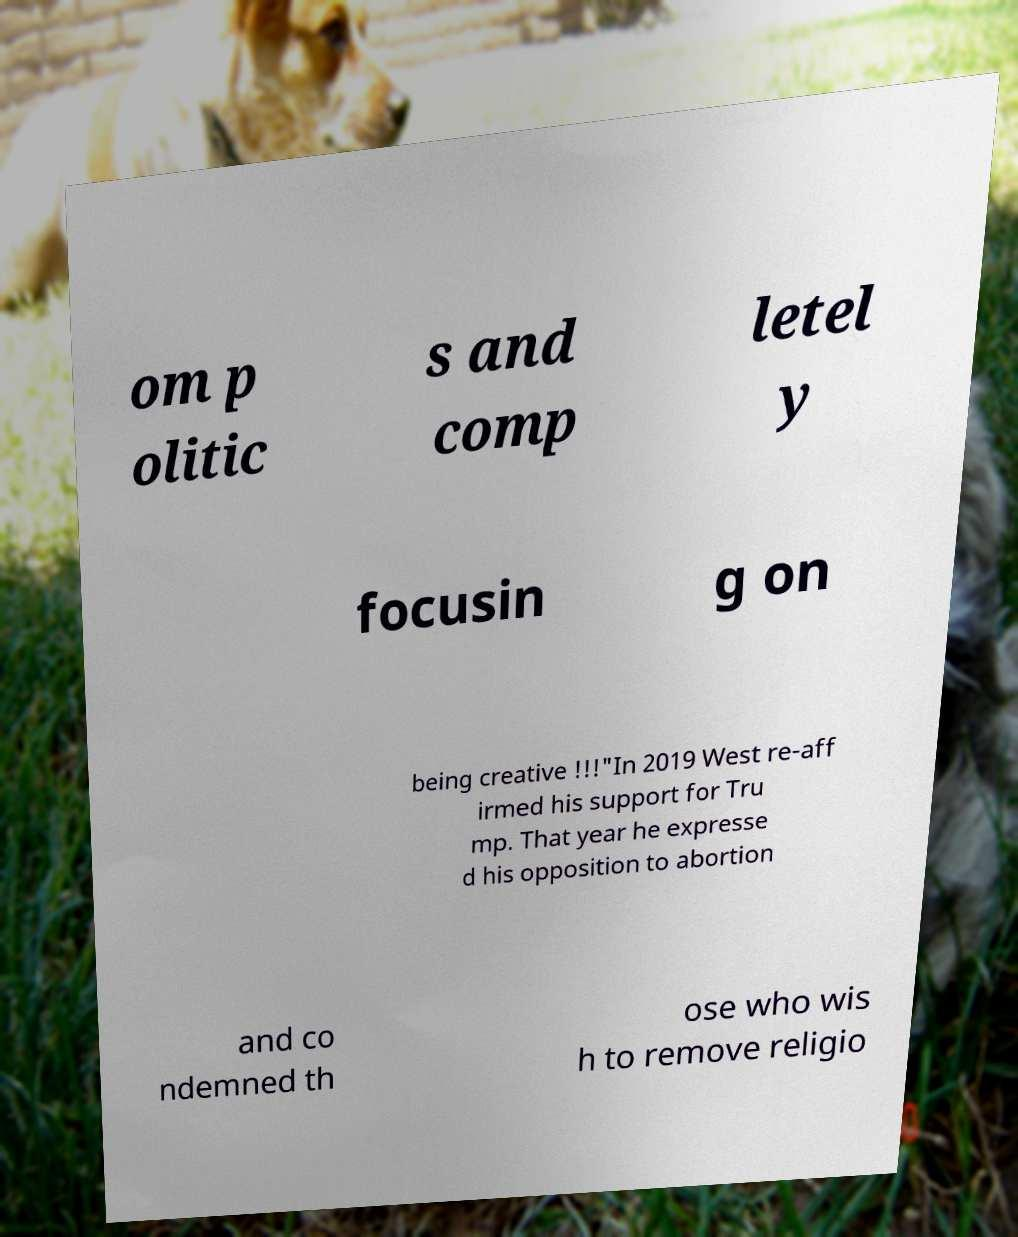There's text embedded in this image that I need extracted. Can you transcribe it verbatim? om p olitic s and comp letel y focusin g on being creative !!!"In 2019 West re-aff irmed his support for Tru mp. That year he expresse d his opposition to abortion and co ndemned th ose who wis h to remove religio 